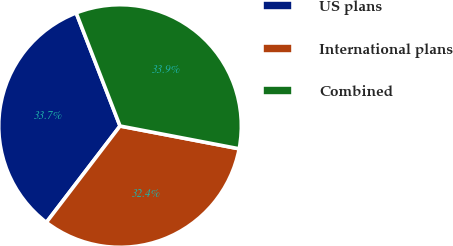Convert chart to OTSL. <chart><loc_0><loc_0><loc_500><loc_500><pie_chart><fcel>US plans<fcel>International plans<fcel>Combined<nl><fcel>33.73%<fcel>32.38%<fcel>33.89%<nl></chart> 